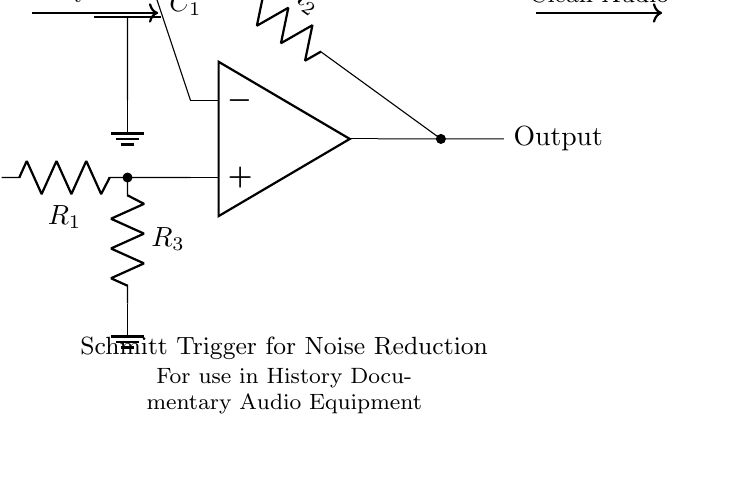What type of circuit is depicted? The circuit shown is a Schmitt Trigger, which is used for converting a noisy signal into a cleaner digital signal. This is evident from the specific arrangement of the op-amp configuration and the feedback mechanism.
Answer: Schmitt Trigger What components are present in the circuit? The components illustrated include an operational amplifier, three resistors, and one capacitor. The resistors are labeled R1, R2, and R3, while the capacitor is labeled C1, providing specific identification based on the schematic.
Answer: Operational amplifier, resistors, and capacitor What is the function of the capacitor in this circuit? The capacitor in this Schmitt Trigger circuit is used for noise reduction by stabilizing the threshold voltage and filtering out high-frequency noise signals. This is important for maintaining a clean audio output, as indicated by its placement in the feedback loop.
Answer: Noise reduction Which signal enters the circuit? The input to the circuit signifies the "Noisy Audio," as shown by the labeled arrow pointing toward the input node. This indicates that the original audio signal is imperfect and must be processed.
Answer: Noisy Audio What does the output signify in this circuit? The output of the circuit represents the "Clean Audio," which is derived from the processed input after noise reduction, as indicated by the labeled arrow pointing out from the output node.
Answer: Clean Audio What role do resistors R1 and R2 play? Resistors R1 and R2 are part of the feedback network that sets the input threshold levels for the Schmitt Trigger. They help determine how the circuit reacts to the noisy input signal, making sure that the output transitions at the correct voltage levels.
Answer: Set threshold levels 